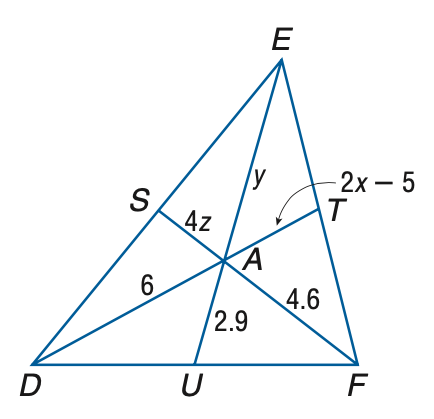Answer the mathemtical geometry problem and directly provide the correct option letter.
Question: Points S, T, and U are the midpoints of D E, E F, and D F, respectively. Find y.
Choices: A: 2.9 B: 4.0 C: 4.6 D: 5.8 D 